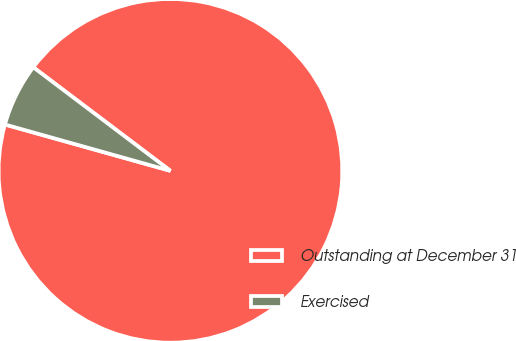Convert chart. <chart><loc_0><loc_0><loc_500><loc_500><pie_chart><fcel>Outstanding at December 31<fcel>Exercised<nl><fcel>94.05%<fcel>5.95%<nl></chart> 